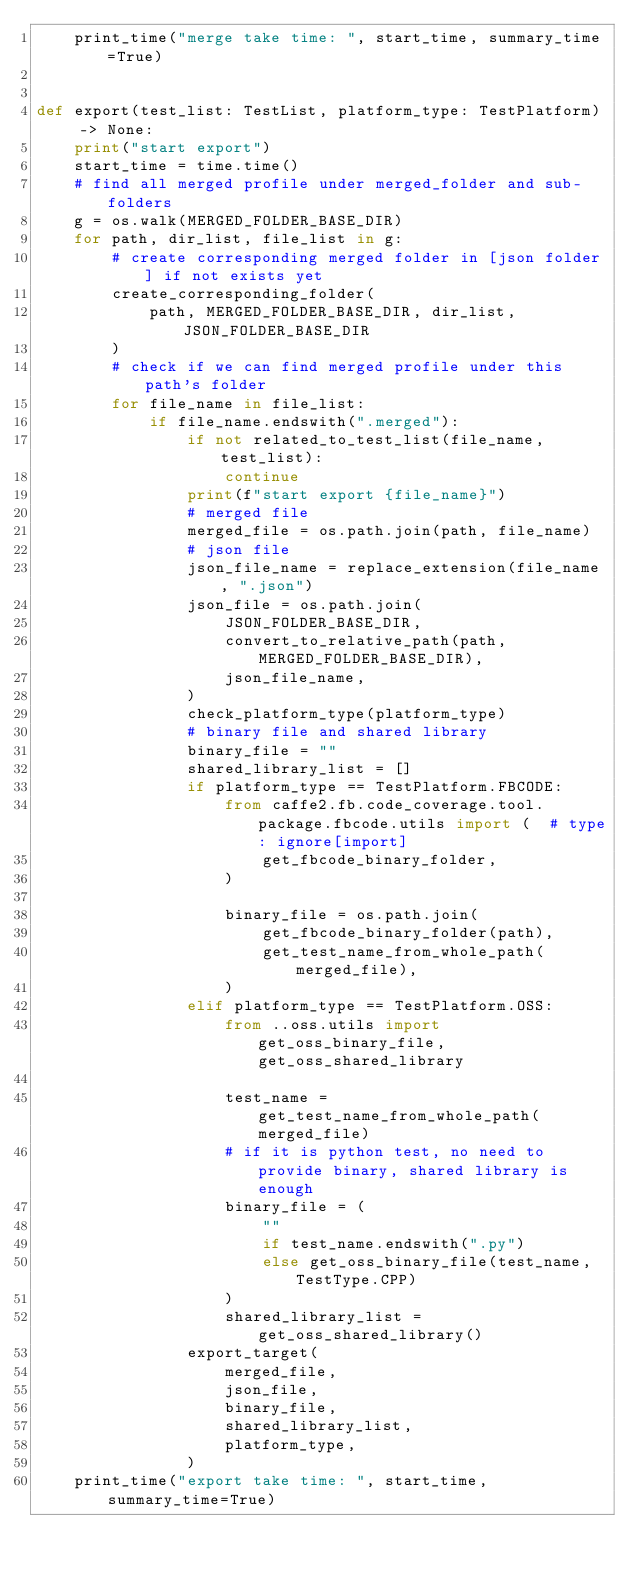Convert code to text. <code><loc_0><loc_0><loc_500><loc_500><_Python_>    print_time("merge take time: ", start_time, summary_time=True)


def export(test_list: TestList, platform_type: TestPlatform) -> None:
    print("start export")
    start_time = time.time()
    # find all merged profile under merged_folder and sub-folders
    g = os.walk(MERGED_FOLDER_BASE_DIR)
    for path, dir_list, file_list in g:
        # create corresponding merged folder in [json folder] if not exists yet
        create_corresponding_folder(
            path, MERGED_FOLDER_BASE_DIR, dir_list, JSON_FOLDER_BASE_DIR
        )
        # check if we can find merged profile under this path's folder
        for file_name in file_list:
            if file_name.endswith(".merged"):
                if not related_to_test_list(file_name, test_list):
                    continue
                print(f"start export {file_name}")
                # merged file
                merged_file = os.path.join(path, file_name)
                # json file
                json_file_name = replace_extension(file_name, ".json")
                json_file = os.path.join(
                    JSON_FOLDER_BASE_DIR,
                    convert_to_relative_path(path, MERGED_FOLDER_BASE_DIR),
                    json_file_name,
                )
                check_platform_type(platform_type)
                # binary file and shared library
                binary_file = ""
                shared_library_list = []
                if platform_type == TestPlatform.FBCODE:
                    from caffe2.fb.code_coverage.tool.package.fbcode.utils import (  # type: ignore[import]
                        get_fbcode_binary_folder,
                    )

                    binary_file = os.path.join(
                        get_fbcode_binary_folder(path),
                        get_test_name_from_whole_path(merged_file),
                    )
                elif platform_type == TestPlatform.OSS:
                    from ..oss.utils import get_oss_binary_file, get_oss_shared_library

                    test_name = get_test_name_from_whole_path(merged_file)
                    # if it is python test, no need to provide binary, shared library is enough
                    binary_file = (
                        ""
                        if test_name.endswith(".py")
                        else get_oss_binary_file(test_name, TestType.CPP)
                    )
                    shared_library_list = get_oss_shared_library()
                export_target(
                    merged_file,
                    json_file,
                    binary_file,
                    shared_library_list,
                    platform_type,
                )
    print_time("export take time: ", start_time, summary_time=True)
</code> 